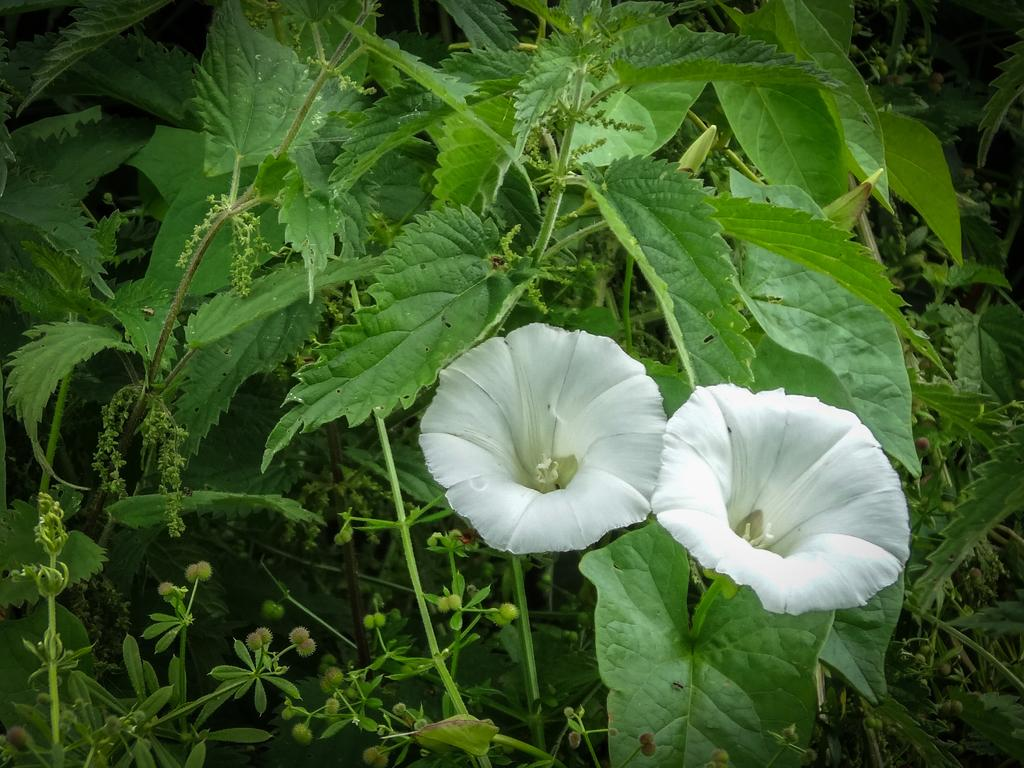How many white-colored flowers are in the image? There are two white-colored flowers in the image. What other elements can be seen in the image besides the flowers? There are leaves and stems visible in the image. What type of angle can be seen in the image? There is no angle present in the image; it features flowers, leaves, and stems. Can you spot a bear in the image? There is no bear present in the image. Is there a clam visible in the image? There is no clam present in the image. 